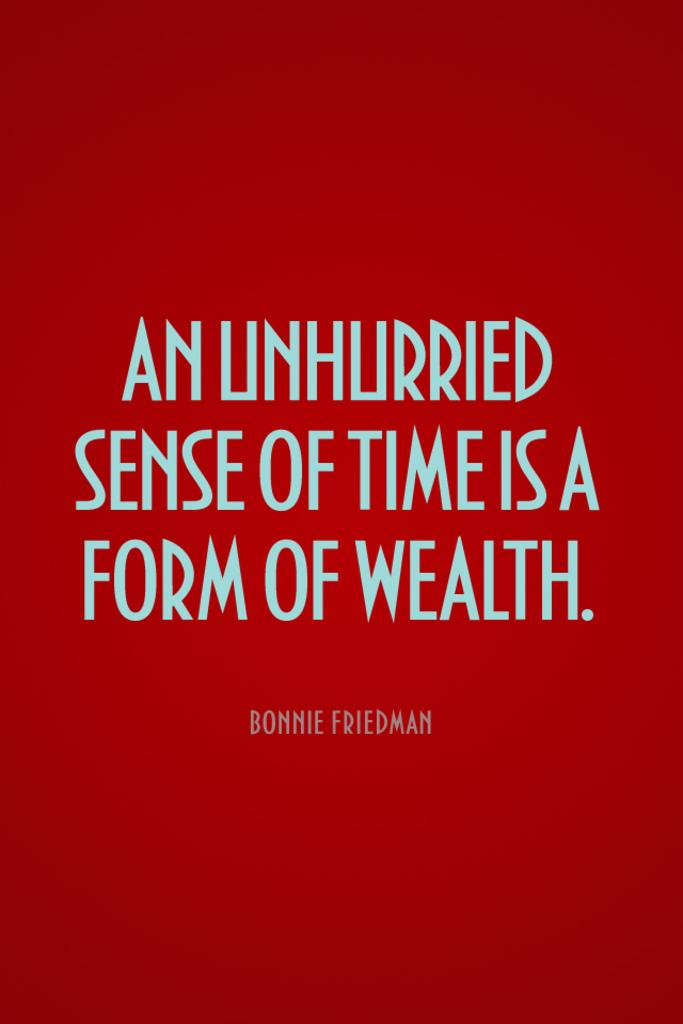<image>
Provide a brief description of the given image. An Unhurried Sense of Time is a Form of Wealth, Bonnie Friedman is written against a red background. 